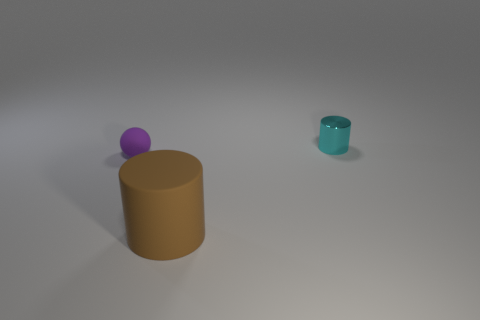Add 3 small purple balls. How many objects exist? 6 Subtract all cylinders. How many objects are left? 1 Subtract all tiny green rubber things. Subtract all small metal objects. How many objects are left? 2 Add 3 small spheres. How many small spheres are left? 4 Add 3 cyan metal cylinders. How many cyan metal cylinders exist? 4 Subtract 0 blue balls. How many objects are left? 3 